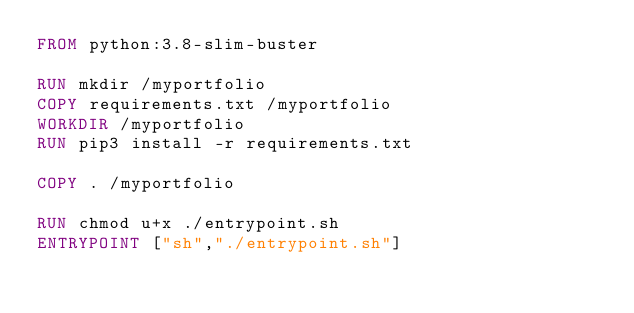Convert code to text. <code><loc_0><loc_0><loc_500><loc_500><_Dockerfile_>FROM python:3.8-slim-buster

RUN mkdir /myportfolio
COPY requirements.txt /myportfolio
WORKDIR /myportfolio
RUN pip3 install -r requirements.txt

COPY . /myportfolio

RUN chmod u+x ./entrypoint.sh
ENTRYPOINT ["sh","./entrypoint.sh"]
</code> 